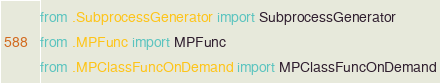<code> <loc_0><loc_0><loc_500><loc_500><_Python_>from .SubprocessGenerator import SubprocessGenerator
from .MPFunc import MPFunc
from .MPClassFuncOnDemand import MPClassFuncOnDemand</code> 